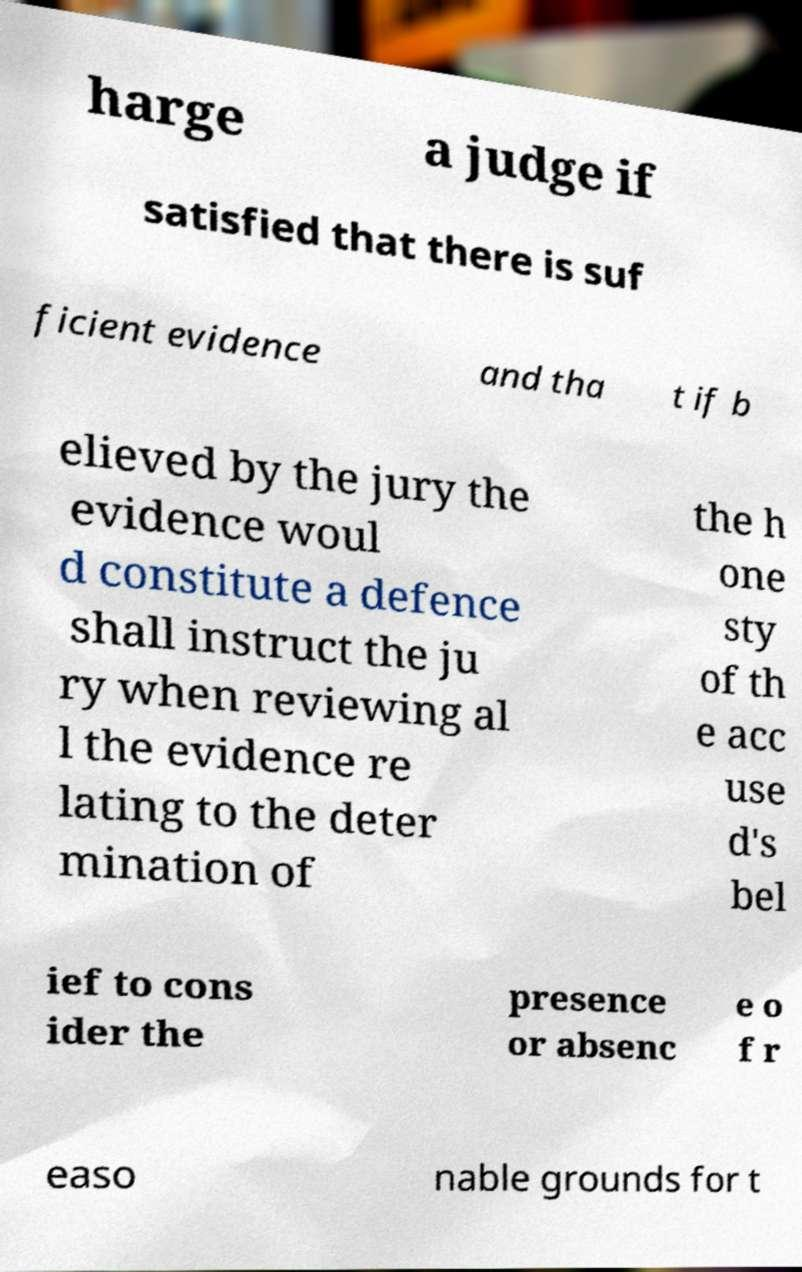Could you extract and type out the text from this image? harge a judge if satisfied that there is suf ficient evidence and tha t if b elieved by the jury the evidence woul d constitute a defence shall instruct the ju ry when reviewing al l the evidence re lating to the deter mination of the h one sty of th e acc use d's bel ief to cons ider the presence or absenc e o f r easo nable grounds for t 